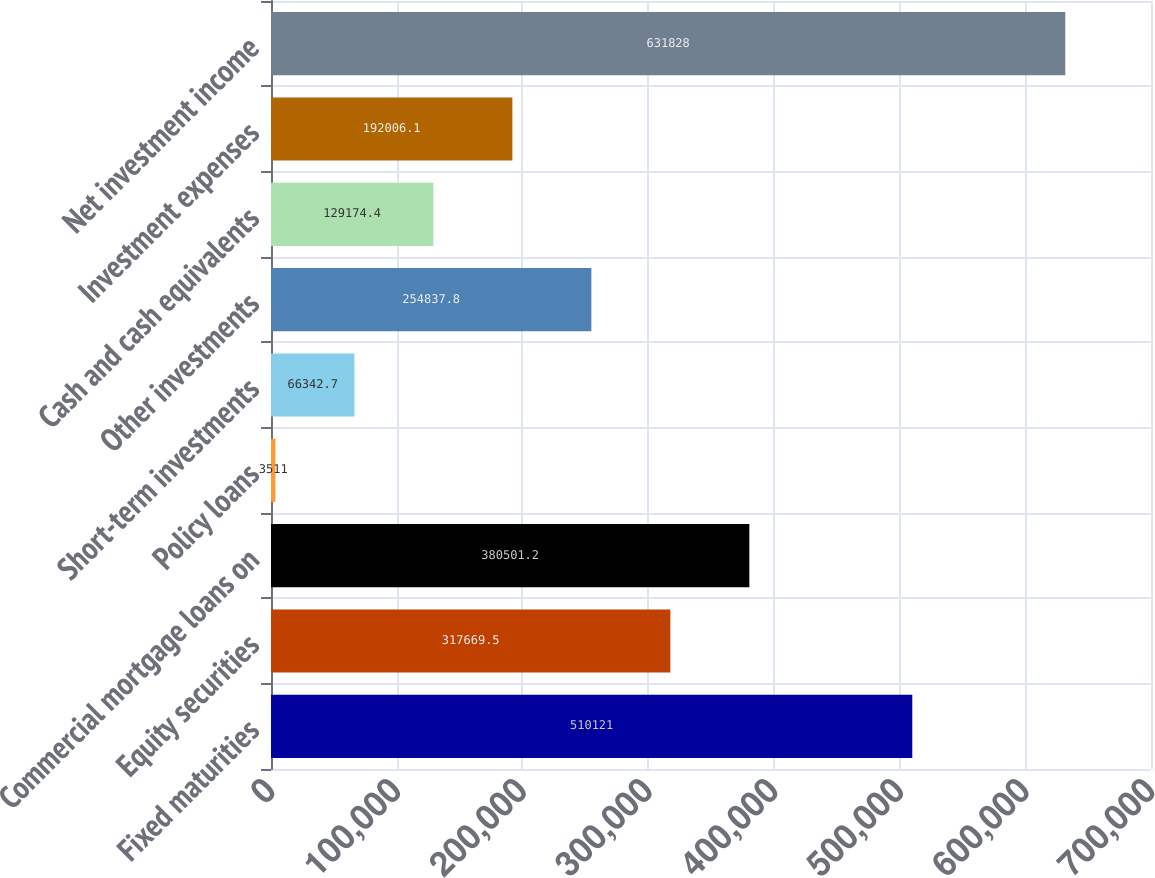Convert chart. <chart><loc_0><loc_0><loc_500><loc_500><bar_chart><fcel>Fixed maturities<fcel>Equity securities<fcel>Commercial mortgage loans on<fcel>Policy loans<fcel>Short-term investments<fcel>Other investments<fcel>Cash and cash equivalents<fcel>Investment expenses<fcel>Net investment income<nl><fcel>510121<fcel>317670<fcel>380501<fcel>3511<fcel>66342.7<fcel>254838<fcel>129174<fcel>192006<fcel>631828<nl></chart> 